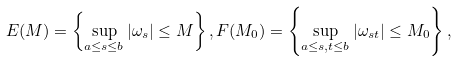Convert formula to latex. <formula><loc_0><loc_0><loc_500><loc_500>E ( M ) = \left \{ \sup _ { a \leq s \leq b } | \omega _ { s } | \leq M \right \} , F ( M _ { 0 } ) = \left \{ \sup _ { a \leq s , t \leq b } | \omega _ { s t } | \leq M _ { 0 } \right \} ,</formula> 